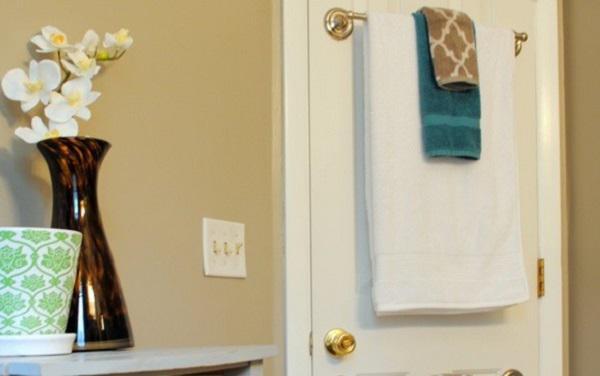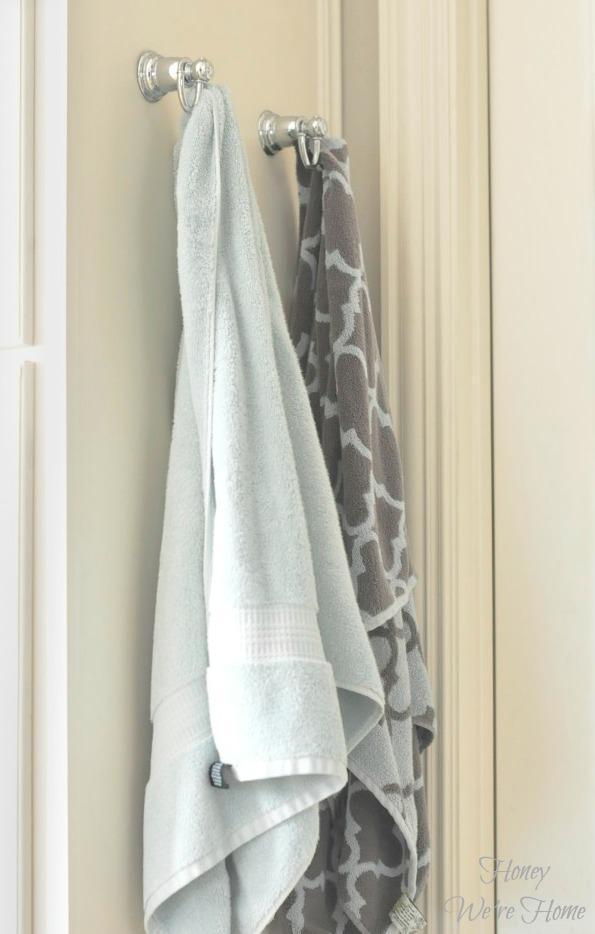The first image is the image on the left, the second image is the image on the right. Given the left and right images, does the statement "Exactly two towels hang from hooks in one image." hold true? Answer yes or no. Yes. 